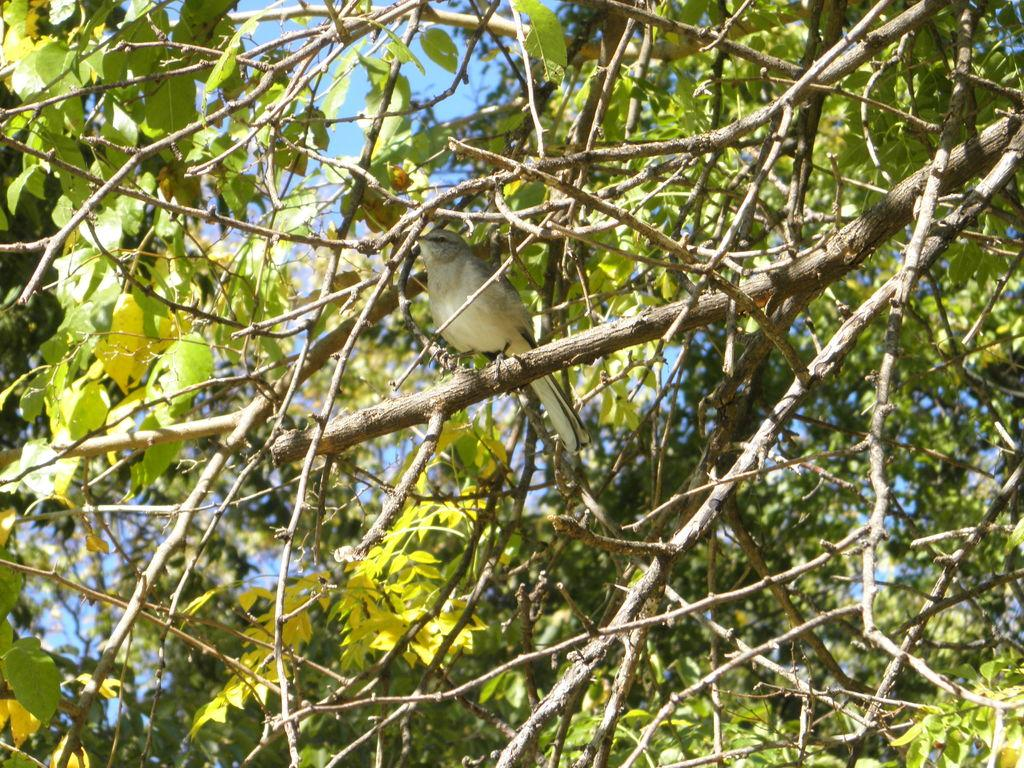What can be seen in the background of the image? The sky is visible in the background of the image. What type of vegetation is present in the image? There are leaves and branches in the image. Can you describe the bird in the image? There is a bird on a branch in the image. What date is marked on the calendar in the image? There is no calendar present in the image. How does the bird look at the viewer in the image? The bird is not looking at the viewer in the image; it is perched on a branch. 